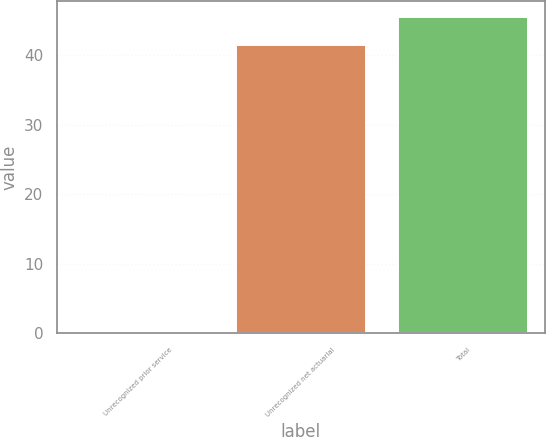Convert chart. <chart><loc_0><loc_0><loc_500><loc_500><bar_chart><fcel>Unrecognized prior service<fcel>Unrecognized net actuarial<fcel>Total<nl><fcel>0.1<fcel>41.4<fcel>45.54<nl></chart> 